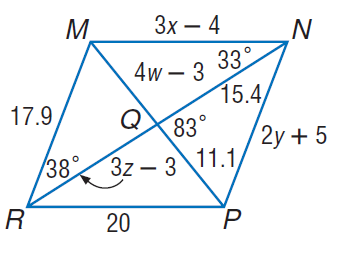Answer the mathemtical geometry problem and directly provide the correct option letter.
Question: Use parallelogram M N P R to find m \angle M Q N.
Choices: A: 83 B: 97 C: 103 D: 107 B 